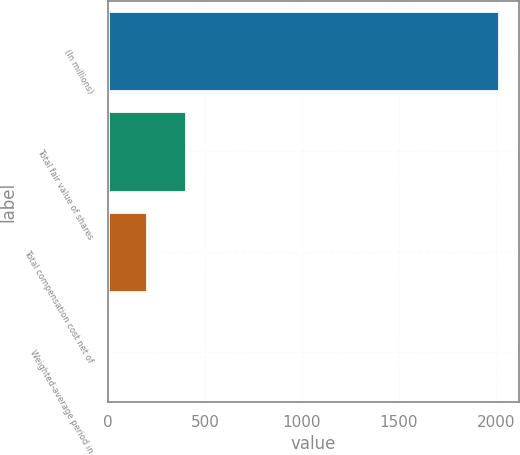Convert chart to OTSL. <chart><loc_0><loc_0><loc_500><loc_500><bar_chart><fcel>(In millions)<fcel>Total fair value of shares<fcel>Total compensation cost net of<fcel>Weighted-average period in<nl><fcel>2017<fcel>405<fcel>203.5<fcel>2<nl></chart> 